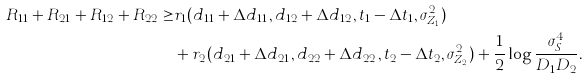Convert formula to latex. <formula><loc_0><loc_0><loc_500><loc_500>R _ { 1 1 } + R _ { 2 1 } + R _ { 1 2 } + R _ { 2 2 } \geq & r _ { 1 } ( d _ { 1 1 } + \Delta d _ { 1 1 } , d _ { 1 2 } + \Delta d _ { 1 2 } , t _ { 1 } - \Delta t _ { 1 } , \sigma _ { Z _ { 1 } } ^ { 2 } ) \\ & + r _ { 2 } ( d _ { 2 1 } + \Delta d _ { 2 1 } , d _ { 2 2 } + \Delta d _ { 2 2 } , t _ { 2 } - \Delta t _ { 2 } , \sigma _ { Z _ { 2 } } ^ { 2 } ) + \frac { 1 } { 2 } \log \frac { \sigma _ { S } ^ { 4 } } { D _ { 1 } D _ { 2 } } .</formula> 